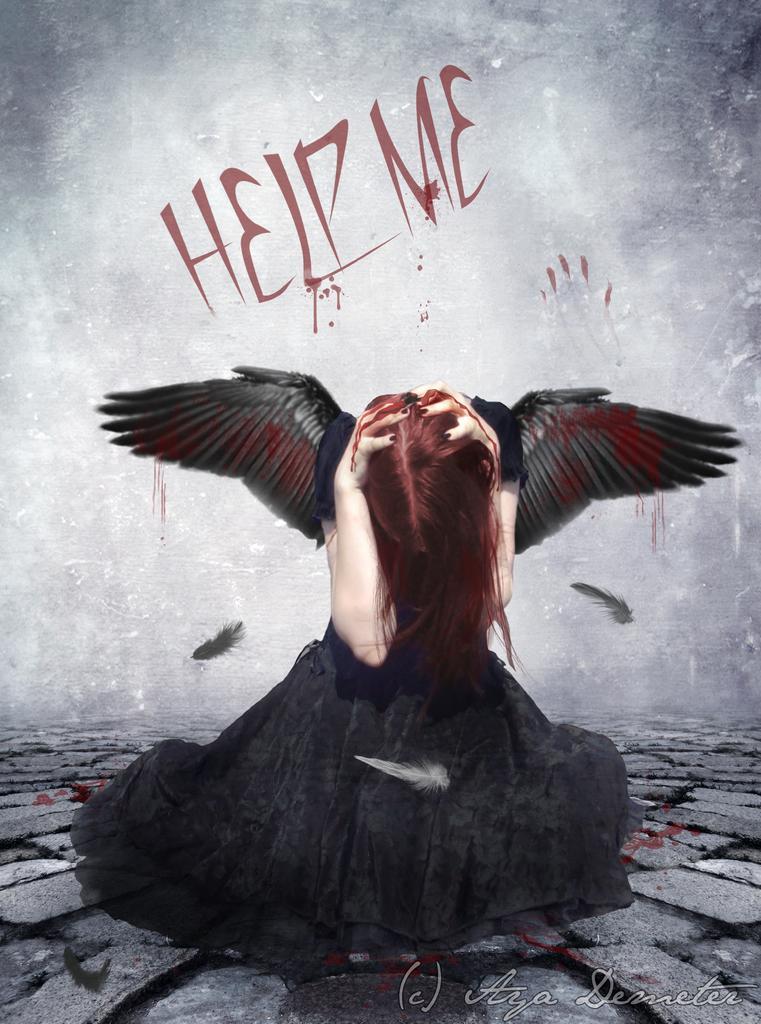Describe this image in one or two sentences. In this image, in the middle, we can see a bird. In the background, we can see a wall which is in black and white color. At the bottom, we can see some stones. 